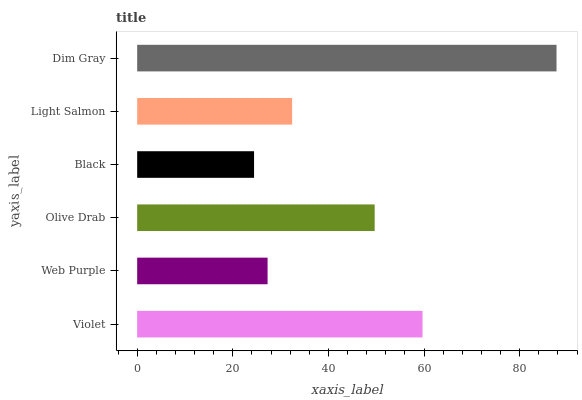Is Black the minimum?
Answer yes or no. Yes. Is Dim Gray the maximum?
Answer yes or no. Yes. Is Web Purple the minimum?
Answer yes or no. No. Is Web Purple the maximum?
Answer yes or no. No. Is Violet greater than Web Purple?
Answer yes or no. Yes. Is Web Purple less than Violet?
Answer yes or no. Yes. Is Web Purple greater than Violet?
Answer yes or no. No. Is Violet less than Web Purple?
Answer yes or no. No. Is Olive Drab the high median?
Answer yes or no. Yes. Is Light Salmon the low median?
Answer yes or no. Yes. Is Web Purple the high median?
Answer yes or no. No. Is Olive Drab the low median?
Answer yes or no. No. 